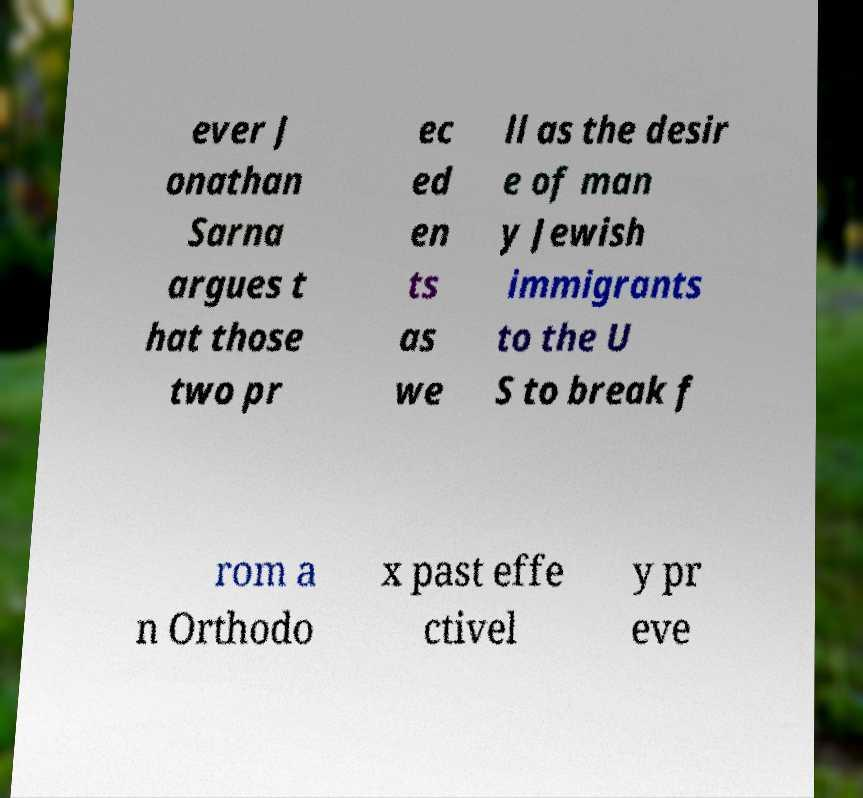Can you accurately transcribe the text from the provided image for me? ever J onathan Sarna argues t hat those two pr ec ed en ts as we ll as the desir e of man y Jewish immigrants to the U S to break f rom a n Orthodo x past effe ctivel y pr eve 